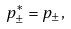Convert formula to latex. <formula><loc_0><loc_0><loc_500><loc_500>p ^ { * } _ { \pm } = p _ { \pm } ,</formula> 